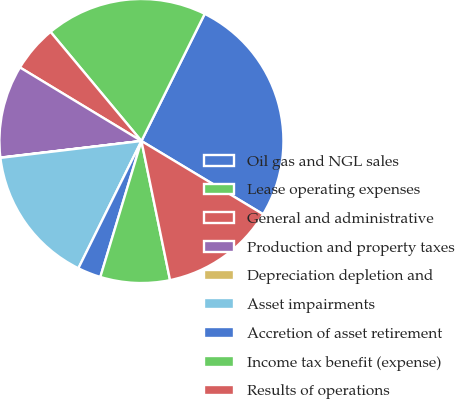<chart> <loc_0><loc_0><loc_500><loc_500><pie_chart><fcel>Oil gas and NGL sales<fcel>Lease operating expenses<fcel>General and administrative<fcel>Production and property taxes<fcel>Depreciation depletion and<fcel>Asset impairments<fcel>Accretion of asset retirement<fcel>Income tax benefit (expense)<fcel>Results of operations<nl><fcel>26.27%<fcel>18.4%<fcel>5.28%<fcel>10.53%<fcel>0.03%<fcel>15.78%<fcel>2.65%<fcel>7.9%<fcel>13.15%<nl></chart> 